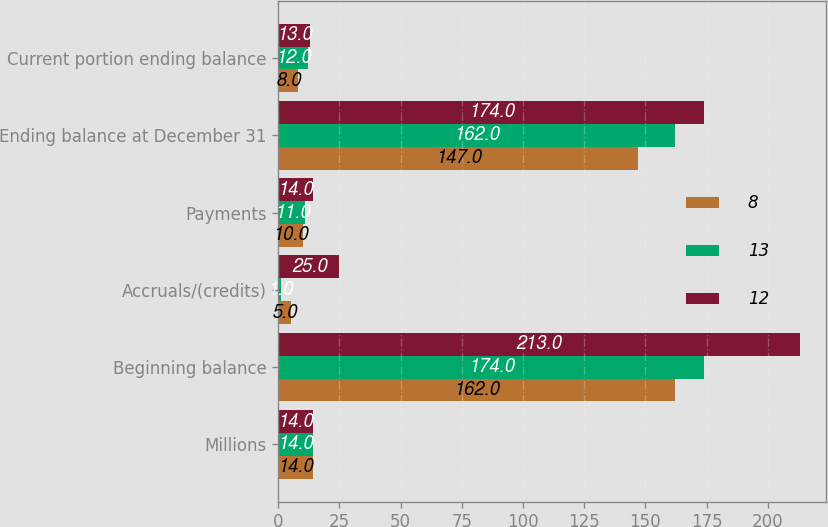Convert chart to OTSL. <chart><loc_0><loc_0><loc_500><loc_500><stacked_bar_chart><ecel><fcel>Millions<fcel>Beginning balance<fcel>Accruals/(credits)<fcel>Payments<fcel>Ending balance at December 31<fcel>Current portion ending balance<nl><fcel>8<fcel>14<fcel>162<fcel>5<fcel>10<fcel>147<fcel>8<nl><fcel>13<fcel>14<fcel>174<fcel>1<fcel>11<fcel>162<fcel>12<nl><fcel>12<fcel>14<fcel>213<fcel>25<fcel>14<fcel>174<fcel>13<nl></chart> 